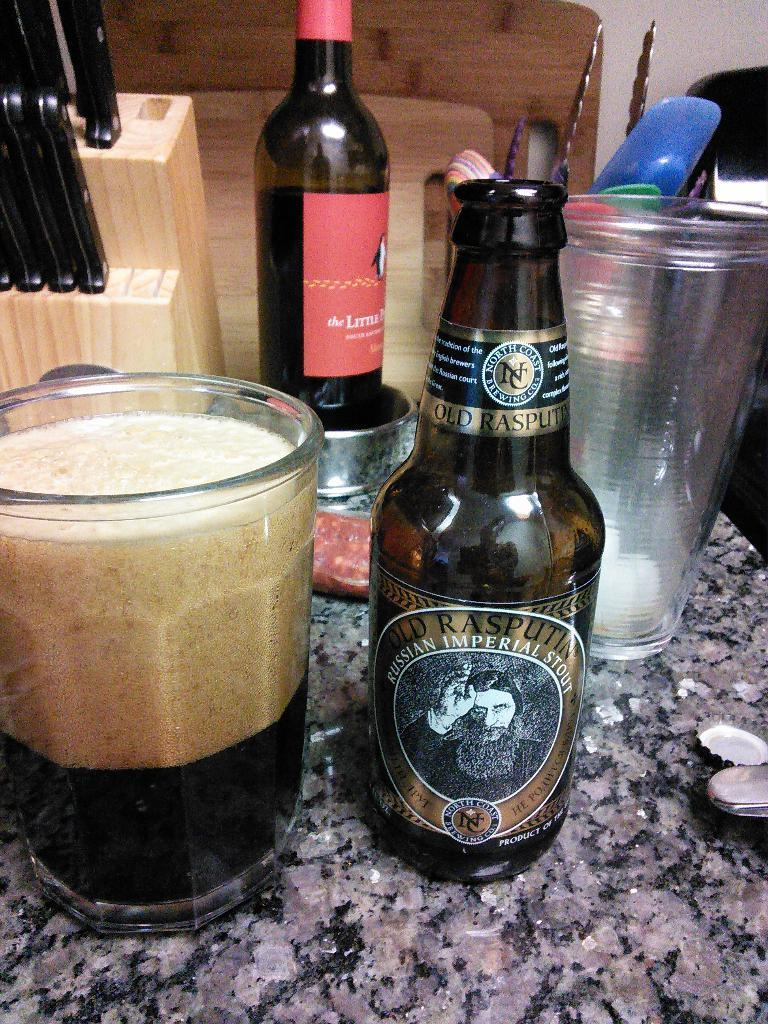<image>
Write a terse but informative summary of the picture. A counter with a wine bottle, knives and a glass and bottle of beer from North Coast Brewing. 